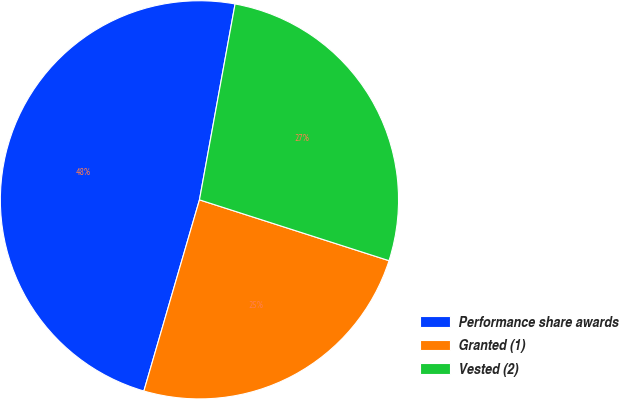<chart> <loc_0><loc_0><loc_500><loc_500><pie_chart><fcel>Performance share awards<fcel>Granted (1)<fcel>Vested (2)<nl><fcel>48.36%<fcel>24.56%<fcel>27.08%<nl></chart> 